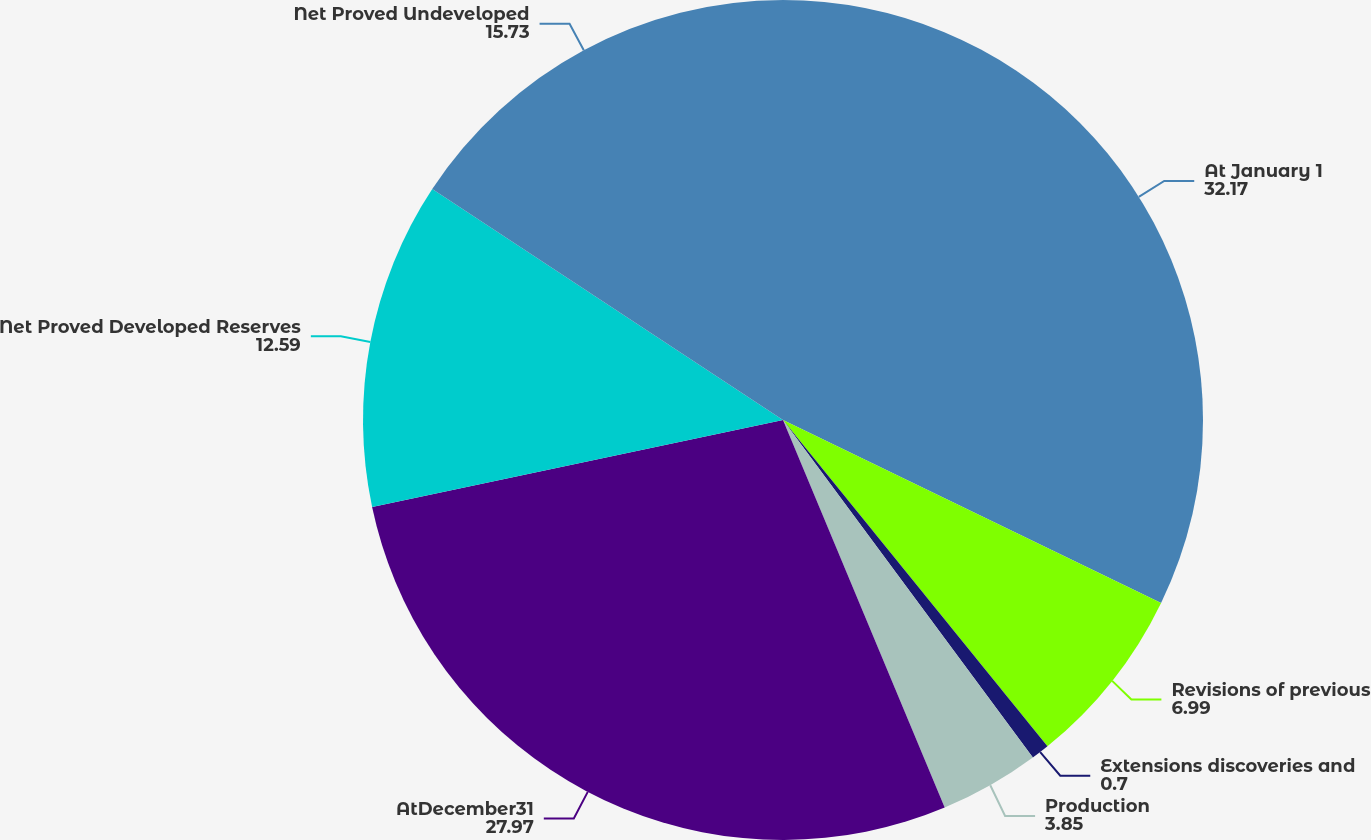Convert chart. <chart><loc_0><loc_0><loc_500><loc_500><pie_chart><fcel>At January 1<fcel>Revisions of previous<fcel>Extensions discoveries and<fcel>Production<fcel>AtDecember31<fcel>Net Proved Developed Reserves<fcel>Net Proved Undeveloped<nl><fcel>32.17%<fcel>6.99%<fcel>0.7%<fcel>3.85%<fcel>27.97%<fcel>12.59%<fcel>15.73%<nl></chart> 